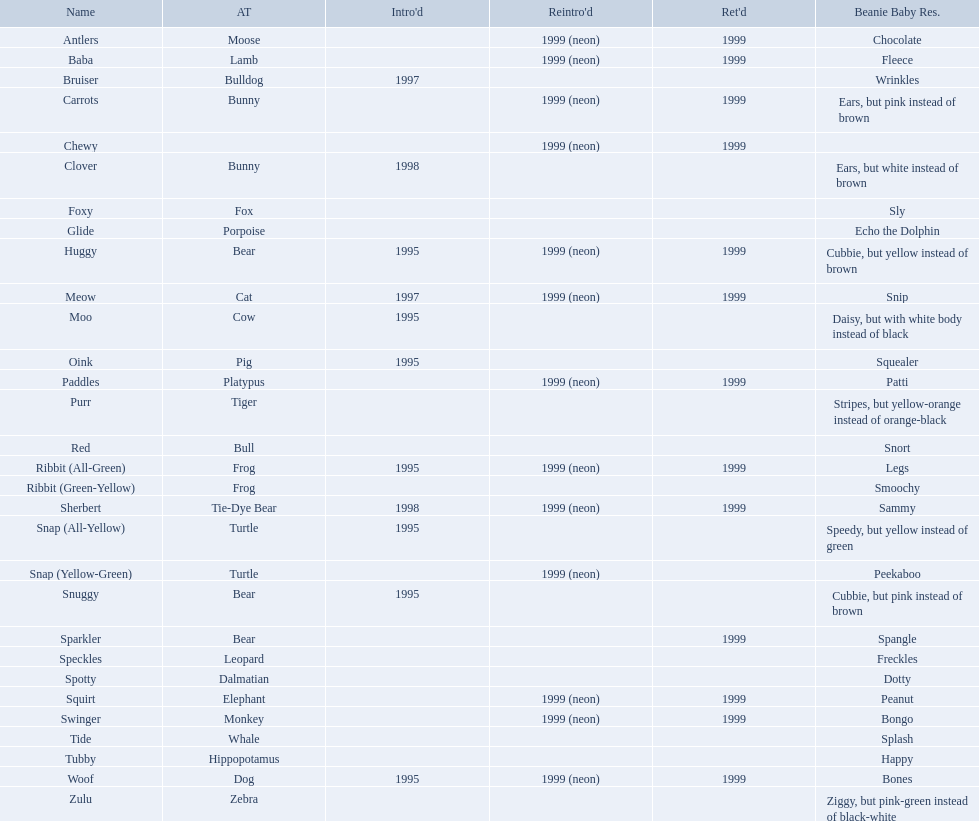What animals are pillow pals? Moose, Lamb, Bulldog, Bunny, Bunny, Fox, Porpoise, Bear, Cat, Cow, Pig, Platypus, Tiger, Bull, Frog, Frog, Tie-Dye Bear, Turtle, Turtle, Bear, Bear, Leopard, Dalmatian, Elephant, Monkey, Whale, Hippopotamus, Dog, Zebra. What is the name of the dalmatian? Spotty. Which of the listed pillow pals lack information in at least 3 categories? Chewy, Foxy, Glide, Purr, Red, Ribbit (Green-Yellow), Speckles, Spotty, Tide, Tubby, Zulu. Of those, which one lacks information in the animal type category? Chewy. What are the names listed? Antlers, Baba, Bruiser, Carrots, Chewy, Clover, Foxy, Glide, Huggy, Meow, Moo, Oink, Paddles, Purr, Red, Ribbit (All-Green), Ribbit (Green-Yellow), Sherbert, Snap (All-Yellow), Snap (Yellow-Green), Snuggy, Sparkler, Speckles, Spotty, Squirt, Swinger, Tide, Tubby, Woof, Zulu. Of these, which is the only pet without an animal type listed? Chewy. 